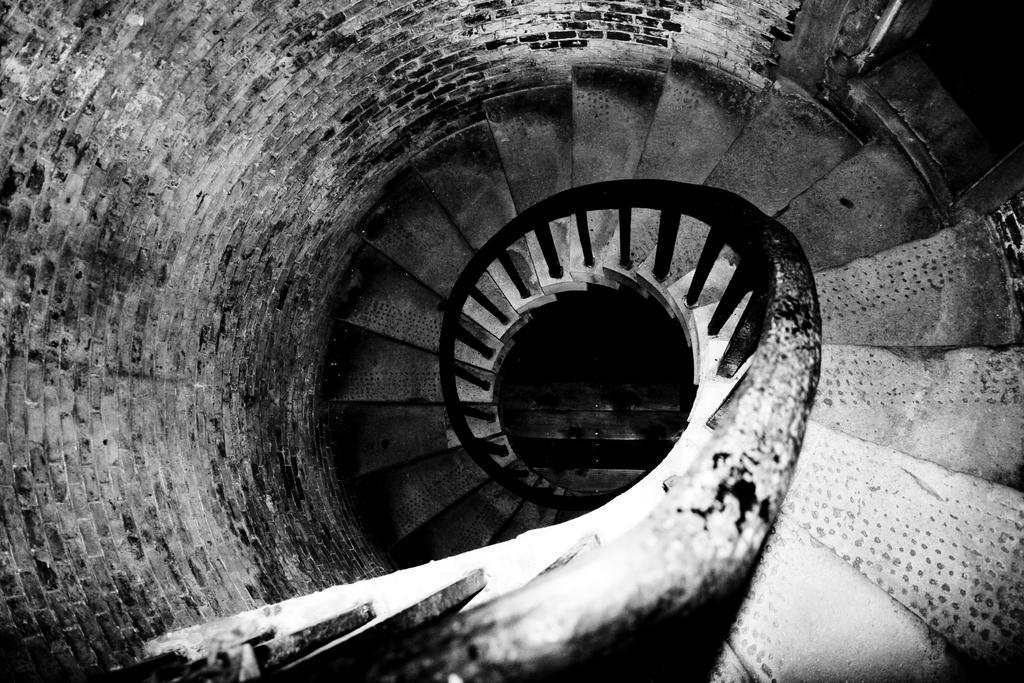Please provide a concise description of this image. In this picture I can see the stairs, railing and the wall. I see that this is a white and black image. 